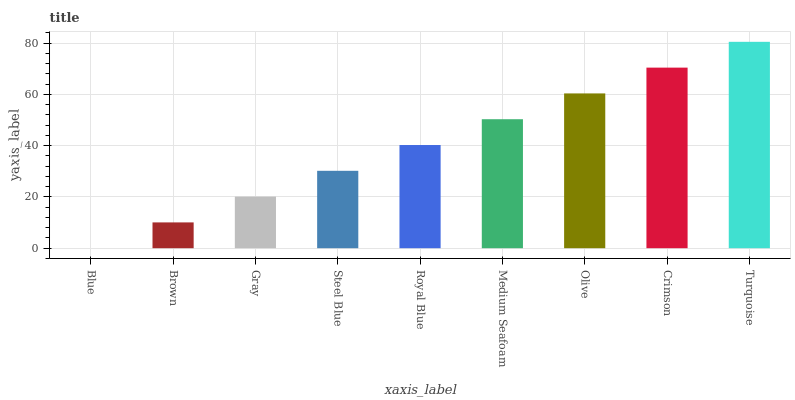Is Blue the minimum?
Answer yes or no. Yes. Is Turquoise the maximum?
Answer yes or no. Yes. Is Brown the minimum?
Answer yes or no. No. Is Brown the maximum?
Answer yes or no. No. Is Brown greater than Blue?
Answer yes or no. Yes. Is Blue less than Brown?
Answer yes or no. Yes. Is Blue greater than Brown?
Answer yes or no. No. Is Brown less than Blue?
Answer yes or no. No. Is Royal Blue the high median?
Answer yes or no. Yes. Is Royal Blue the low median?
Answer yes or no. Yes. Is Steel Blue the high median?
Answer yes or no. No. Is Olive the low median?
Answer yes or no. No. 